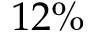<formula> <loc_0><loc_0><loc_500><loc_500>1 2 \%</formula> 